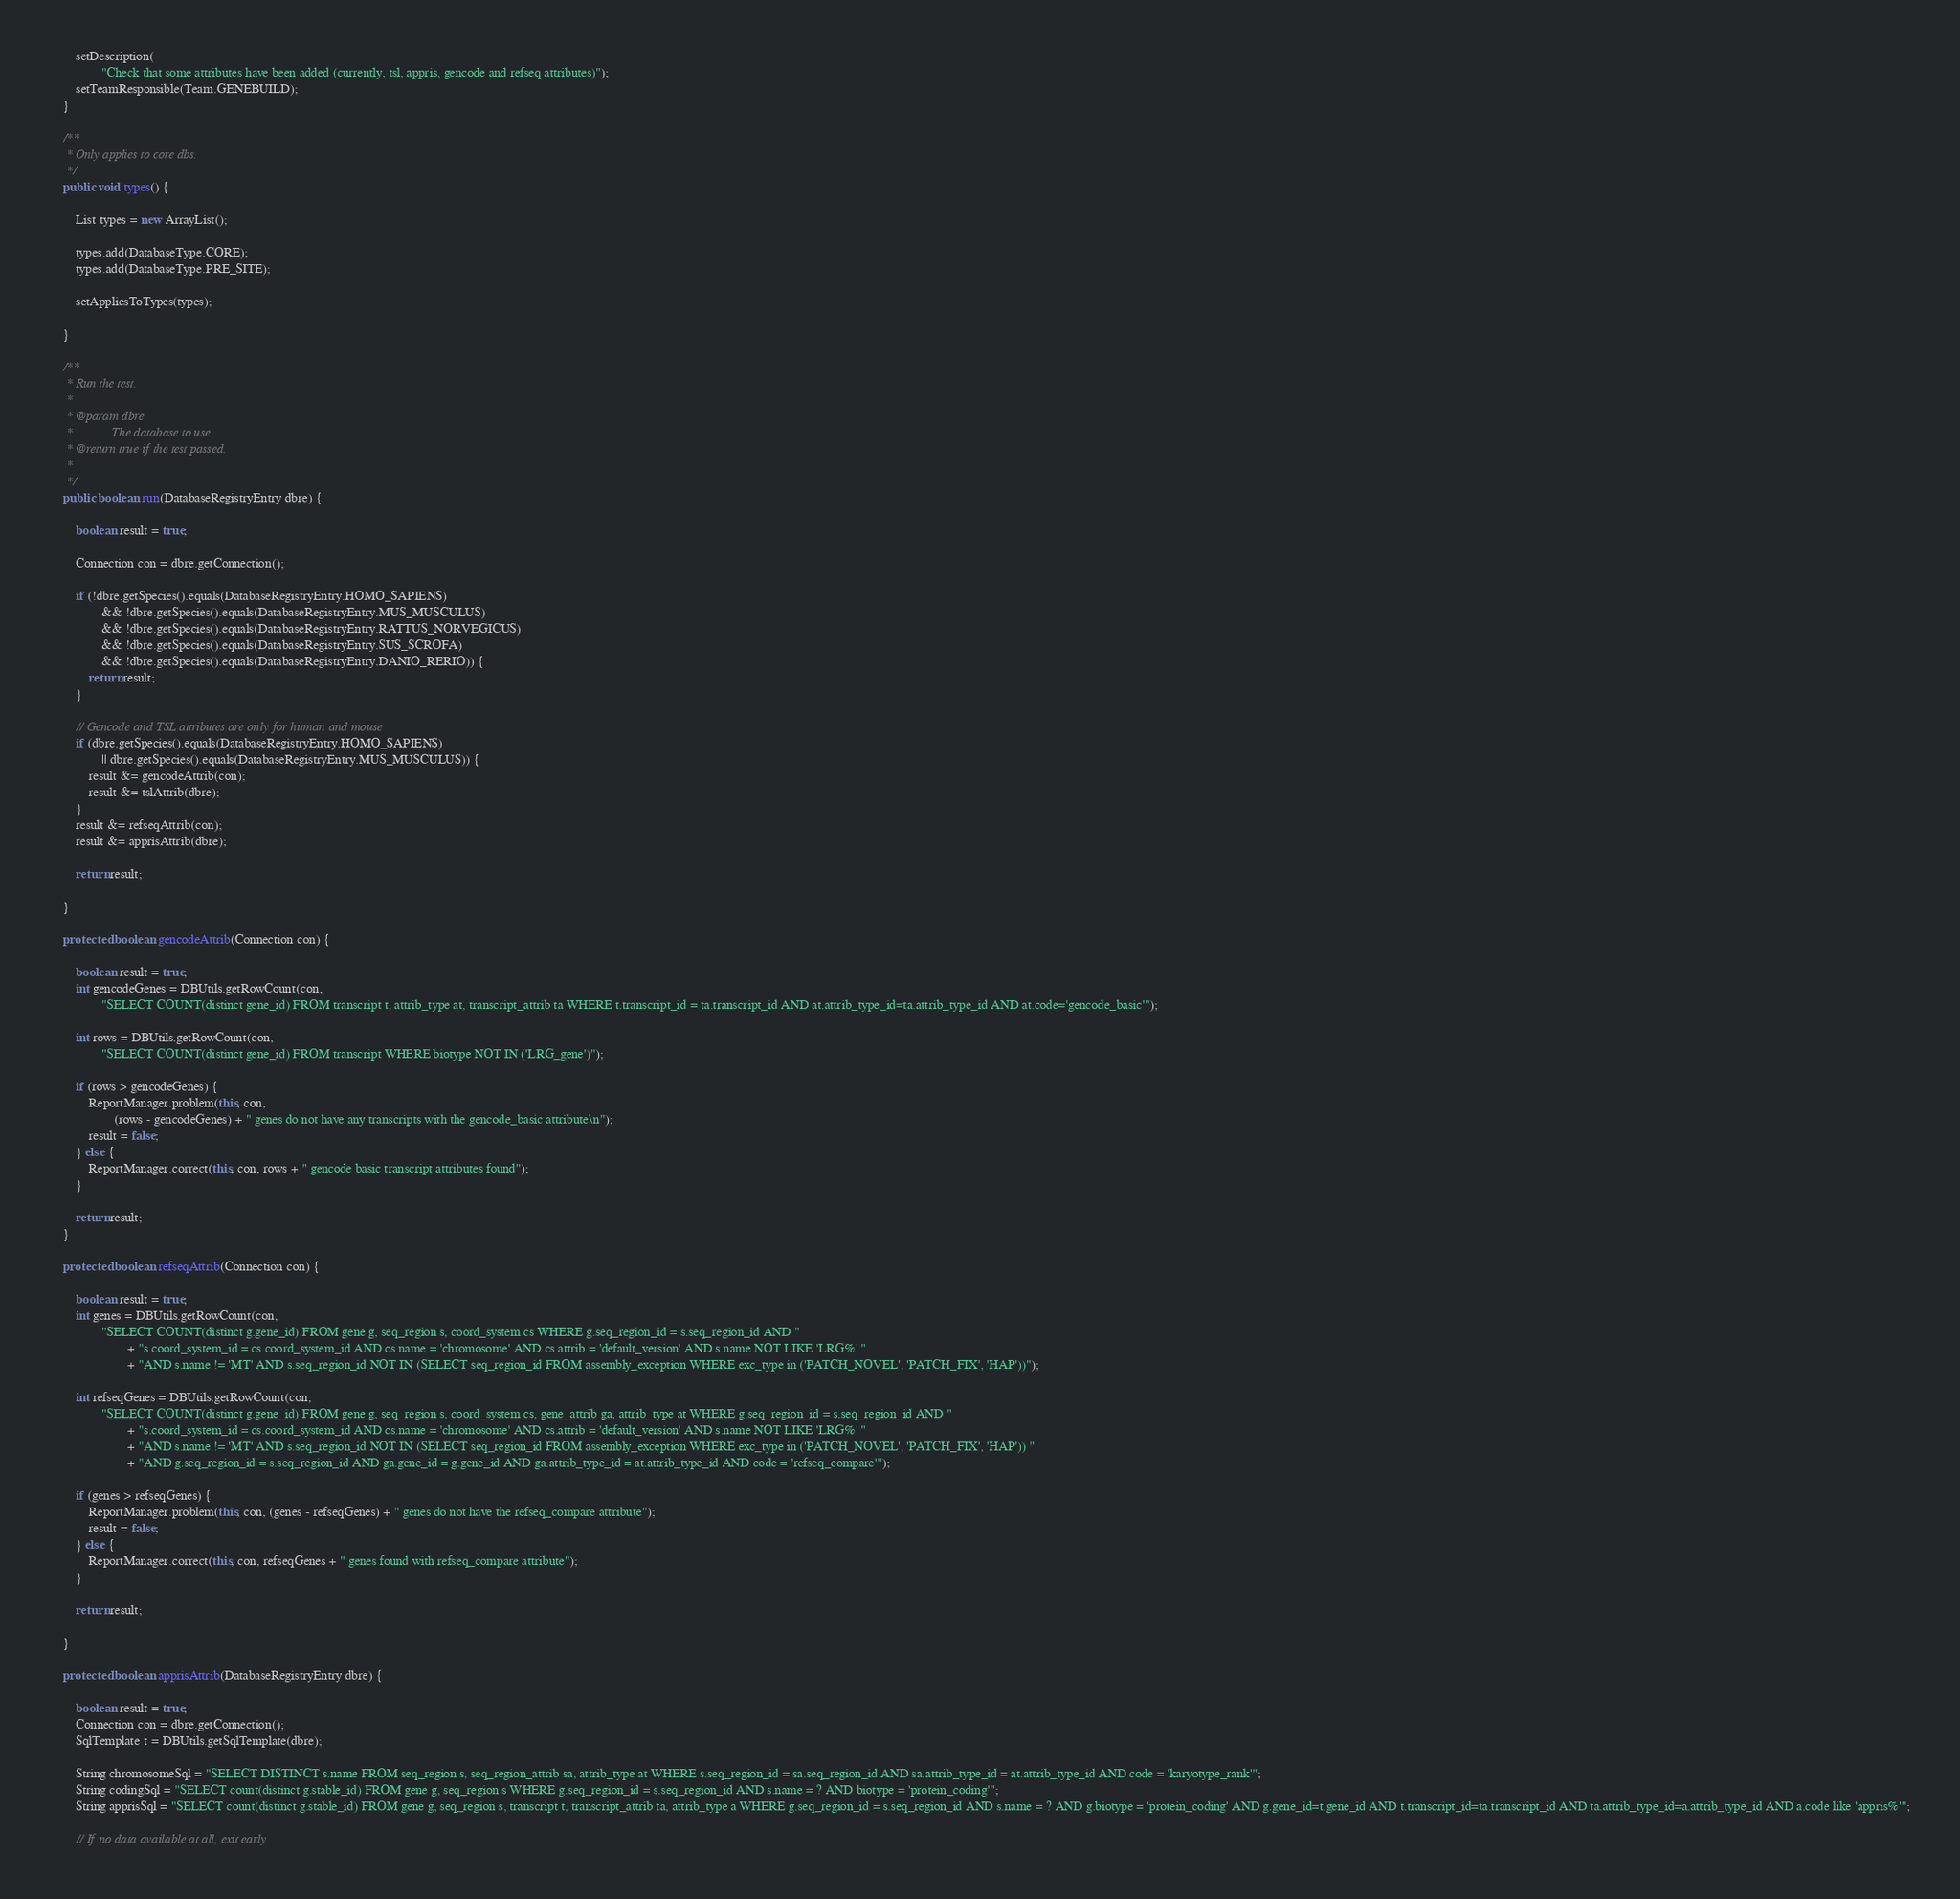<code> <loc_0><loc_0><loc_500><loc_500><_Java_>		setDescription(
				"Check that some attributes have been added (currently, tsl, appris, gencode and refseq attributes)");
		setTeamResponsible(Team.GENEBUILD);
	}

	/**
	 * Only applies to core dbs.
	 */
	public void types() {

		List types = new ArrayList();

		types.add(DatabaseType.CORE);
		types.add(DatabaseType.PRE_SITE);

		setAppliesToTypes(types);

	}

	/**
	 * Run the test.
	 * 
	 * @param dbre
	 *            The database to use.
	 * @return true if the test passed.
	 * 
	 */
	public boolean run(DatabaseRegistryEntry dbre) {

		boolean result = true;

		Connection con = dbre.getConnection();

		if (!dbre.getSpecies().equals(DatabaseRegistryEntry.HOMO_SAPIENS)
				&& !dbre.getSpecies().equals(DatabaseRegistryEntry.MUS_MUSCULUS)
				&& !dbre.getSpecies().equals(DatabaseRegistryEntry.RATTUS_NORVEGICUS)
				&& !dbre.getSpecies().equals(DatabaseRegistryEntry.SUS_SCROFA)
				&& !dbre.getSpecies().equals(DatabaseRegistryEntry.DANIO_RERIO)) {
			return result;
		}

		// Gencode and TSL attributes are only for human and mouse
		if (dbre.getSpecies().equals(DatabaseRegistryEntry.HOMO_SAPIENS)
				|| dbre.getSpecies().equals(DatabaseRegistryEntry.MUS_MUSCULUS)) {
			result &= gencodeAttrib(con);
			result &= tslAttrib(dbre);
		}
		result &= refseqAttrib(con);
		result &= apprisAttrib(dbre);

		return result;

	}

	protected boolean gencodeAttrib(Connection con) {

		boolean result = true;
		int gencodeGenes = DBUtils.getRowCount(con,
				"SELECT COUNT(distinct gene_id) FROM transcript t, attrib_type at, transcript_attrib ta WHERE t.transcript_id = ta.transcript_id AND at.attrib_type_id=ta.attrib_type_id AND at.code='gencode_basic'");

		int rows = DBUtils.getRowCount(con,
				"SELECT COUNT(distinct gene_id) FROM transcript WHERE biotype NOT IN ('LRG_gene')");

		if (rows > gencodeGenes) {
			ReportManager.problem(this, con,
					(rows - gencodeGenes) + " genes do not have any transcripts with the gencode_basic attribute\n");
			result = false;
		} else {
			ReportManager.correct(this, con, rows + " gencode basic transcript attributes found");
		}

		return result;
	}

	protected boolean refseqAttrib(Connection con) {

		boolean result = true;
		int genes = DBUtils.getRowCount(con,
				"SELECT COUNT(distinct g.gene_id) FROM gene g, seq_region s, coord_system cs WHERE g.seq_region_id = s.seq_region_id AND "
						+ "s.coord_system_id = cs.coord_system_id AND cs.name = 'chromosome' AND cs.attrib = 'default_version' AND s.name NOT LIKE 'LRG%' "
						+ "AND s.name != 'MT' AND s.seq_region_id NOT IN (SELECT seq_region_id FROM assembly_exception WHERE exc_type in ('PATCH_NOVEL', 'PATCH_FIX', 'HAP'))");

		int refseqGenes = DBUtils.getRowCount(con,
				"SELECT COUNT(distinct g.gene_id) FROM gene g, seq_region s, coord_system cs, gene_attrib ga, attrib_type at WHERE g.seq_region_id = s.seq_region_id AND "
						+ "s.coord_system_id = cs.coord_system_id AND cs.name = 'chromosome' AND cs.attrib = 'default_version' AND s.name NOT LIKE 'LRG%' "
						+ "AND s.name != 'MT' AND s.seq_region_id NOT IN (SELECT seq_region_id FROM assembly_exception WHERE exc_type in ('PATCH_NOVEL', 'PATCH_FIX', 'HAP')) "
						+ "AND g.seq_region_id = s.seq_region_id AND ga.gene_id = g.gene_id AND ga.attrib_type_id = at.attrib_type_id AND code = 'refseq_compare'");

		if (genes > refseqGenes) {
			ReportManager.problem(this, con, (genes - refseqGenes) + " genes do not have the refseq_compare attribute");
			result = false;
		} else {
			ReportManager.correct(this, con, refseqGenes + " genes found with refseq_compare attribute");
		}

		return result;

	}

	protected boolean apprisAttrib(DatabaseRegistryEntry dbre) {

		boolean result = true;
		Connection con = dbre.getConnection();
		SqlTemplate t = DBUtils.getSqlTemplate(dbre);

		String chromosomeSql = "SELECT DISTINCT s.name FROM seq_region s, seq_region_attrib sa, attrib_type at WHERE s.seq_region_id = sa.seq_region_id AND sa.attrib_type_id = at.attrib_type_id AND code = 'karyotype_rank'";
		String codingSql = "SELECT count(distinct g.stable_id) FROM gene g, seq_region s WHERE g.seq_region_id = s.seq_region_id AND s.name = ? AND biotype = 'protein_coding'";
		String apprisSql = "SELECT count(distinct g.stable_id) FROM gene g, seq_region s, transcript t, transcript_attrib ta, attrib_type a WHERE g.seq_region_id = s.seq_region_id AND s.name = ? AND g.biotype = 'protein_coding' AND g.gene_id=t.gene_id AND t.transcript_id=ta.transcript_id AND ta.attrib_type_id=a.attrib_type_id AND a.code like 'appris%'";

		// If no data available at all, exit early</code> 